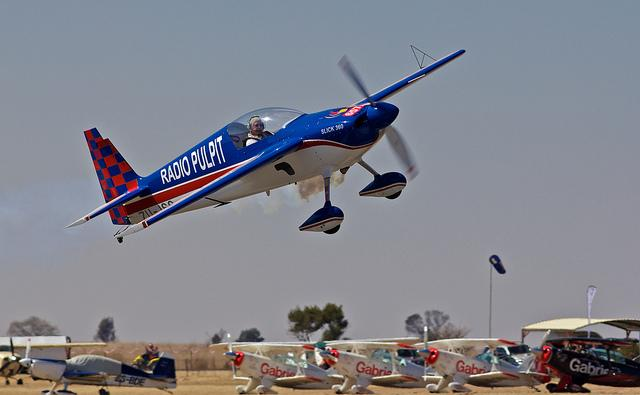What is the man doing in the front of the blue plane? Please explain your reasoning. flying it. The man in the front of the plane is the pilot and he is the one steering the plane. 